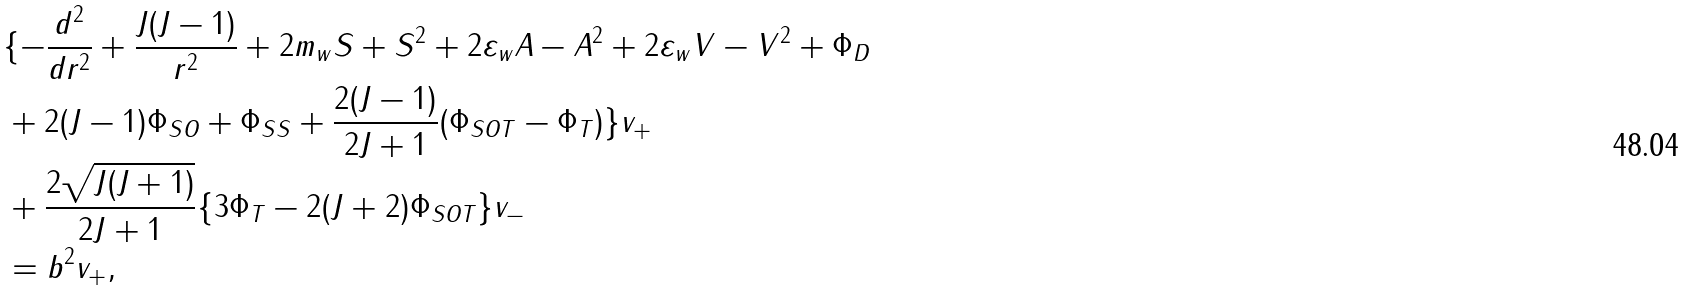<formula> <loc_0><loc_0><loc_500><loc_500>& \{ - \frac { d ^ { 2 } } { d r ^ { 2 } } + \frac { J ( J - 1 ) } { r ^ { 2 } } + 2 m _ { w } S + S ^ { 2 } + 2 \varepsilon _ { w } A - A ^ { 2 } + 2 \varepsilon _ { w } V - V ^ { 2 } + \Phi _ { D } \\ & + 2 ( J - 1 ) \Phi _ { S O } + \Phi _ { S S } + \frac { 2 ( J - 1 ) } { 2 J + 1 } ( \Phi _ { S O T } - \Phi _ { T } ) \} v _ { + } \\ & + \frac { 2 \sqrt { J ( J + 1 ) } } { 2 J + 1 } \{ 3 \Phi _ { T } - 2 ( J + 2 ) \Phi _ { S O T } \} v _ { - } \\ & = b ^ { 2 } v _ { + } ,</formula> 